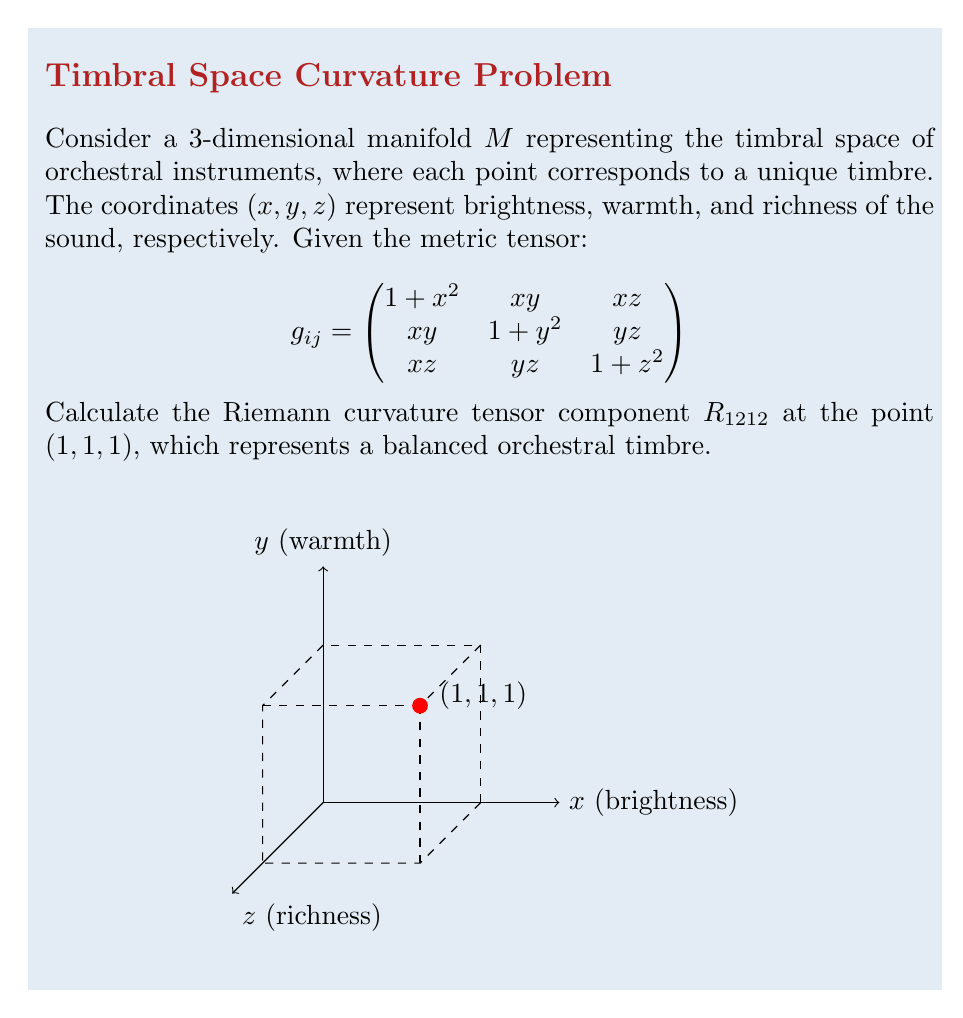Give your solution to this math problem. To calculate $R_{1212}$, we'll follow these steps:

1) The Riemann curvature tensor is given by:
   $$R_{ijkl} = \partial_k \Gamma_{ilj} - \partial_l \Gamma_{ikj} + \Gamma_{ikm}\Gamma_{mlj} - \Gamma_{ilm}\Gamma_{mkj}$$

2) We need to calculate the Christoffel symbols $\Gamma_{ijk}$:
   $$\Gamma_{ijk} = \frac{1}{2}(g_{ij,k} + g_{ik,j} - g_{jk,i})$$

3) For $R_{1212}$, we need $\Gamma_{112}$ and $\Gamma_{122}$:

   $$\Gamma_{112} = \frac{1}{2}(g_{11,2} + g_{12,1} - g_{21,1}) = \frac{1}{2}(0 + y + y) = y$$
   
   $$\Gamma_{122} = \frac{1}{2}(g_{12,2} + g_{12,2} - g_{22,1}) = \frac{1}{2}(x + x - x) = \frac{x}{2}$$

4) Now, we can calculate $R_{1212}$:
   $$R_{1212} = \partial_1 \Gamma_{122} - \partial_2 \Gamma_{112} + \Gamma_{11m}\Gamma_{m22} - \Gamma_{12m}\Gamma_{m12}$$

5) Calculating each term:
   - $\partial_1 \Gamma_{122} = \frac{1}{2}$
   - $\partial_2 \Gamma_{112} = 1$
   - $\Gamma_{11m}\Gamma_{m22} = \Gamma_{111}\Gamma_{122} + \Gamma_{112}\Gamma_{222} + \Gamma_{113}\Gamma_{322} = x \cdot \frac{x}{2} + y \cdot y + z \cdot \frac{y}{2}$
   - $\Gamma_{12m}\Gamma_{m12} = \Gamma_{121}\Gamma_{112} + \Gamma_{122}\Gamma_{212} + \Gamma_{123}\Gamma_{312} = y \cdot y + \frac{x}{2} \cdot x + \frac{z}{2} \cdot z$

6) Substituting the point (1, 1, 1):
   $$R_{1212} = \frac{1}{2} - 1 + (1 \cdot \frac{1}{2} + 1 \cdot 1 + 1 \cdot \frac{1}{2}) - (1 \cdot 1 + \frac{1}{2} \cdot 1 + \frac{1}{2} \cdot 1)$$

7) Simplifying:
   $$R_{1212} = \frac{1}{2} - 1 + 2 - 2 = -\frac{1}{2}$$
Answer: $-\frac{1}{2}$ 